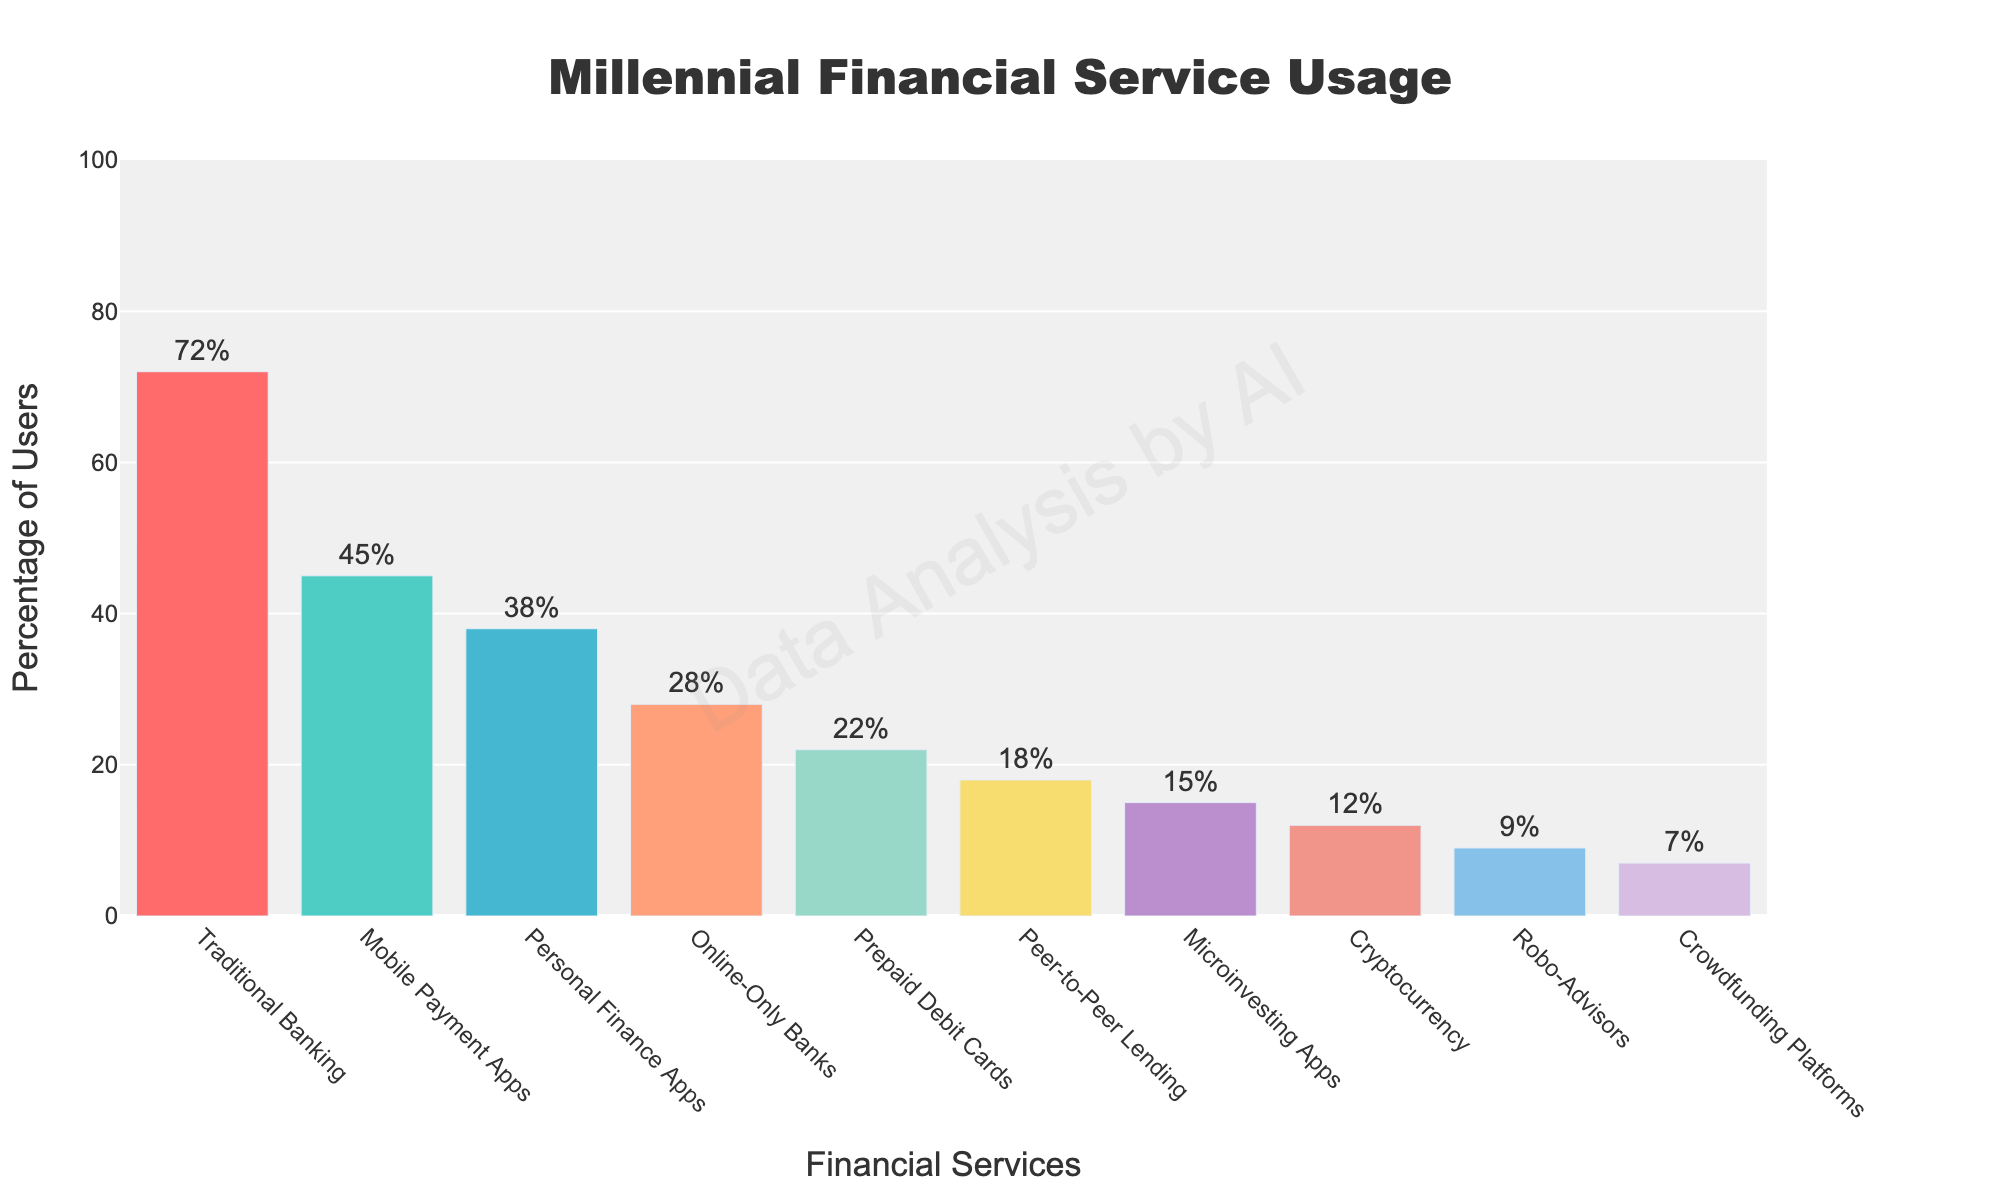Which financial service has the highest percentage of users? The bar representing "Traditional Banking" is the tallest, indicating it has the highest percentage of users at 72%.
Answer: Traditional Banking How much higher is the percentage of users for traditional banking compared to peer-to-peer lending? The percentage of users for traditional banking is 72%, while for peer-to-peer lending it is 18%. The difference is 72% - 18% = 54%.
Answer: 54% What is the combined percentage of users for mobile payment apps and personal finance apps? Mobile Payment Apps have 45% and Personal Finance Apps have 38%. The combined percentage is 45% + 38% = 83%.
Answer: 83% Which service has fewer users: cryptocurrency or microinvesting apps? The bar for Cryptocurrency is at 12%, and the bar for Microinvesting Apps is at 15%. Cryptocurrency has fewer users.
Answer: Cryptocurrency What is the average percentage of users across all the financial services shown? The sum of the percentages is 72 + 18 + 12 + 45 + 9 + 28 + 15 + 7 + 22 + 38 = 266. There are 10 services, so the average is 266/10 = 26.6%.
Answer: 26.6% Compare the numbers of users for online-only banks and prepaid debit cards. Which one has more users? The percentage for Online-Only Banks is 28%, whereas for Prepaid Debit Cards is 22%. Online-Only Banks have more users.
Answer: Online-Only Banks Which service is used less than robo-advisors and more than crowdfunding platforms? Robo-Advisors have 9% and Crowdfunding Platforms have 7%. The only service between these two percentages is Cryptocurrency at 12%.
Answer: Cryptocurrency How much lower is the percentage of users for crowdfunding platforms compared to personal finance apps? Personal Finance Apps have 38%, and Crowdfunding Platforms have 7%. The difference is 38% - 7% = 31%.
Answer: 31% Is the percentage of users for microinvesting apps higher or lower than for prepaid debit cards? The percentage for Microinvesting Apps is 15%, whereas for Prepaid Debit Cards it is 22%. Microinvesting Apps have a lower percentage of users.
Answer: Lower What's the difference in percentage between the highest and lowest used alternative financial service? The highest used alternative financial service is Mobile Payment Apps at 45%, and the lowest is Crowdfunding Platforms at 7%. The difference is 45% - 7% = 38%.
Answer: 38% 